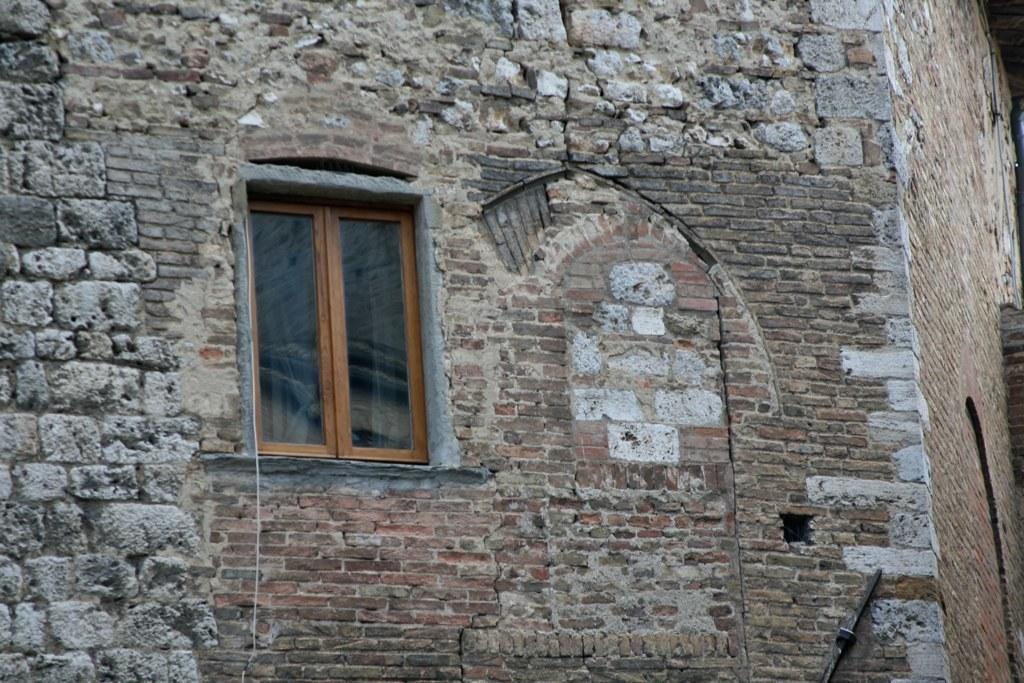How would you summarize this image in a sentence or two? In this image I can see the wall , on the wall there is a window. 